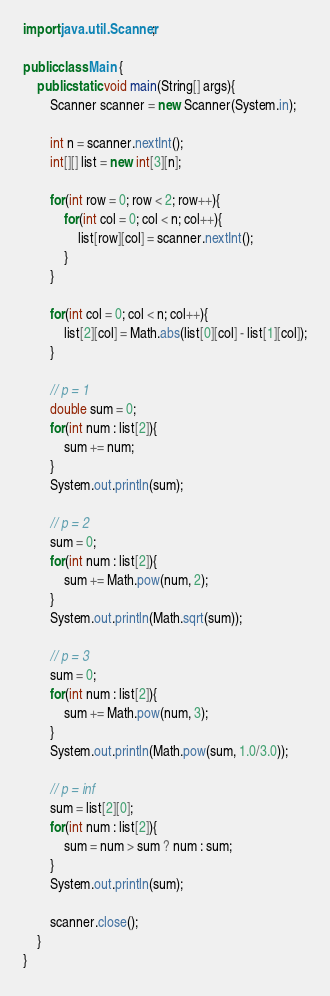Convert code to text. <code><loc_0><loc_0><loc_500><loc_500><_Java_>import java.util.Scanner;

public class Main {
    public static void main(String[] args){
        Scanner scanner = new Scanner(System.in);

        int n = scanner.nextInt();
        int[][] list = new int[3][n];

        for(int row = 0; row < 2; row++){
            for(int col = 0; col < n; col++){
                list[row][col] = scanner.nextInt();
            }
        }

        for(int col = 0; col < n; col++){
            list[2][col] = Math.abs(list[0][col] - list[1][col]);
        }

        // p = 1
        double sum = 0;
        for(int num : list[2]){
            sum += num;
        }
        System.out.println(sum);

        // p = 2
        sum = 0;
        for(int num : list[2]){
            sum += Math.pow(num, 2);
        }
        System.out.println(Math.sqrt(sum));

        // p = 3
        sum = 0;
        for(int num : list[2]){
            sum += Math.pow(num, 3);
        }
        System.out.println(Math.pow(sum, 1.0/3.0));

        // p = inf
        sum = list[2][0];
        for(int num : list[2]){
            sum = num > sum ? num : sum;
        }
        System.out.println(sum);

        scanner.close();
    }
}

</code> 